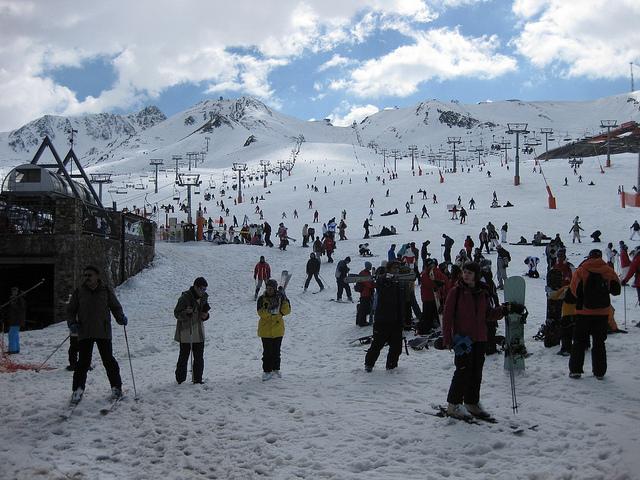What is on the ground?
Give a very brief answer. Snow. Which season is this?
Short answer required. Winter. What are the people doing?
Keep it brief. Skiing. How many skiers are there?
Quick response, please. Hundreds. Is it nighttime or daytime?
Quick response, please. Daytime. What are the items under the people's arms?
Concise answer only. Ski poles. 